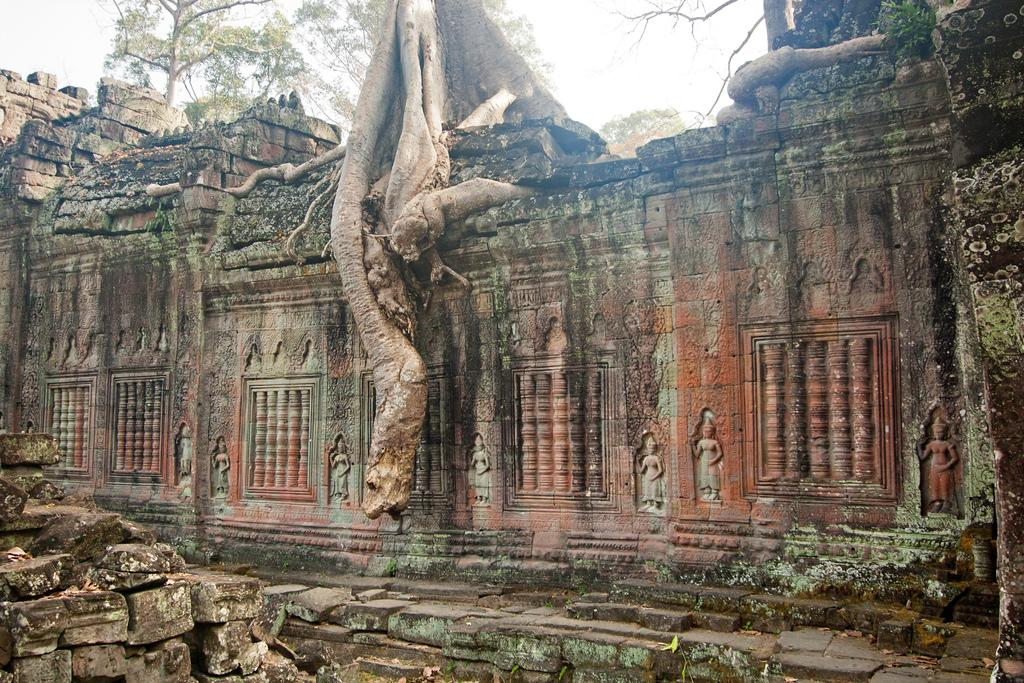What type of structure is depicted in the image? There is a structure that resembles a temple in the image. What can be seen on the walls of the structure? There are sculptures on the walls of the structure. What type of vegetation is visible in the image? There are trees visible in the image. What is visible at the top of the image? The sky is visible at the top of the image. Can you see a band playing music in the image? There is no band playing music in the image. Is anyone swimming in the image? There is no swimming depicted in the image. 